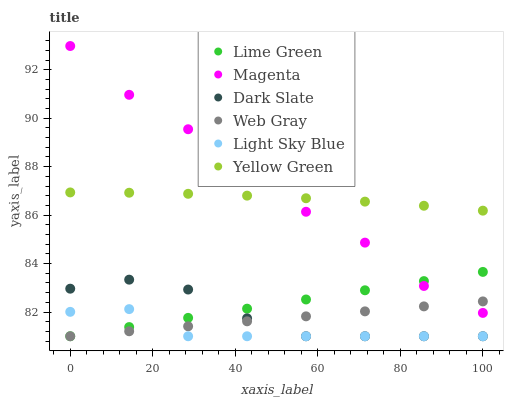Does Light Sky Blue have the minimum area under the curve?
Answer yes or no. Yes. Does Magenta have the maximum area under the curve?
Answer yes or no. Yes. Does Yellow Green have the minimum area under the curve?
Answer yes or no. No. Does Yellow Green have the maximum area under the curve?
Answer yes or no. No. Is Lime Green the smoothest?
Answer yes or no. Yes. Is Magenta the roughest?
Answer yes or no. Yes. Is Yellow Green the smoothest?
Answer yes or no. No. Is Yellow Green the roughest?
Answer yes or no. No. Does Web Gray have the lowest value?
Answer yes or no. Yes. Does Yellow Green have the lowest value?
Answer yes or no. No. Does Magenta have the highest value?
Answer yes or no. Yes. Does Yellow Green have the highest value?
Answer yes or no. No. Is Dark Slate less than Yellow Green?
Answer yes or no. Yes. Is Magenta greater than Dark Slate?
Answer yes or no. Yes. Does Lime Green intersect Web Gray?
Answer yes or no. Yes. Is Lime Green less than Web Gray?
Answer yes or no. No. Is Lime Green greater than Web Gray?
Answer yes or no. No. Does Dark Slate intersect Yellow Green?
Answer yes or no. No. 